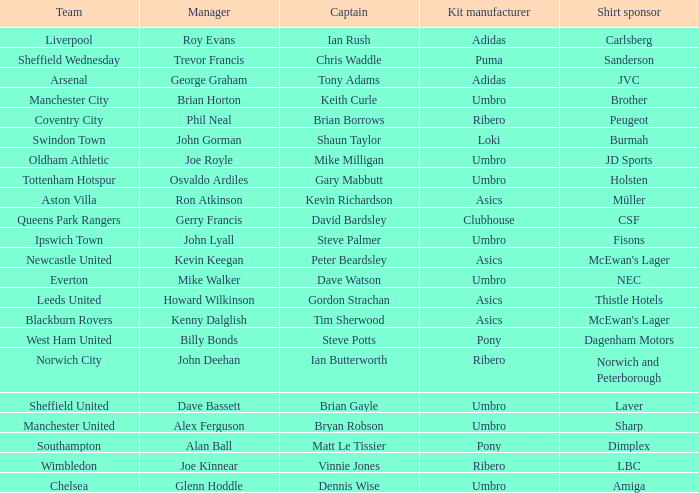What is the kit manufacturer that has billy bonds as the manager? Pony. 